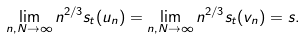<formula> <loc_0><loc_0><loc_500><loc_500>\lim _ { n , N \to \infty } n ^ { 2 / 3 } s _ { t } ( u _ { n } ) = \lim _ { n , N \to \infty } n ^ { 2 / 3 } s _ { t } ( v _ { n } ) = s .</formula> 